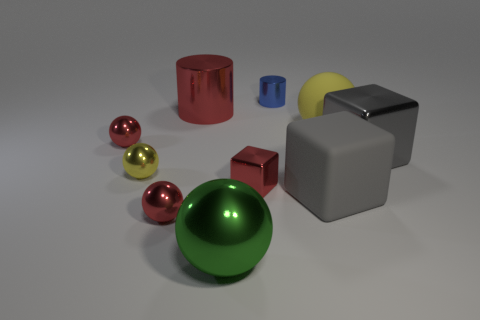Is the number of big spheres that are on the right side of the big rubber cube greater than the number of tiny blue rubber cylinders?
Keep it short and to the point. Yes. Are there any other cubes of the same color as the large rubber block?
Give a very brief answer. Yes. How big is the gray metallic cube?
Offer a terse response. Large. Do the big shiny cylinder and the tiny block have the same color?
Provide a succinct answer. Yes. What number of objects are small yellow cubes or red metallic objects that are to the left of the big shiny block?
Offer a very short reply. 4. How many small metal cylinders are in front of the gray thing left of the metallic thing that is right of the blue shiny cylinder?
Offer a very short reply. 0. There is a thing that is the same color as the big shiny block; what is it made of?
Offer a very short reply. Rubber. What number of tiny things are there?
Your response must be concise. 5. Do the metallic cylinder to the right of the green metal thing and the big green metal ball have the same size?
Ensure brevity in your answer.  No. How many shiny things are either small green balls or tiny red balls?
Your response must be concise. 2. 